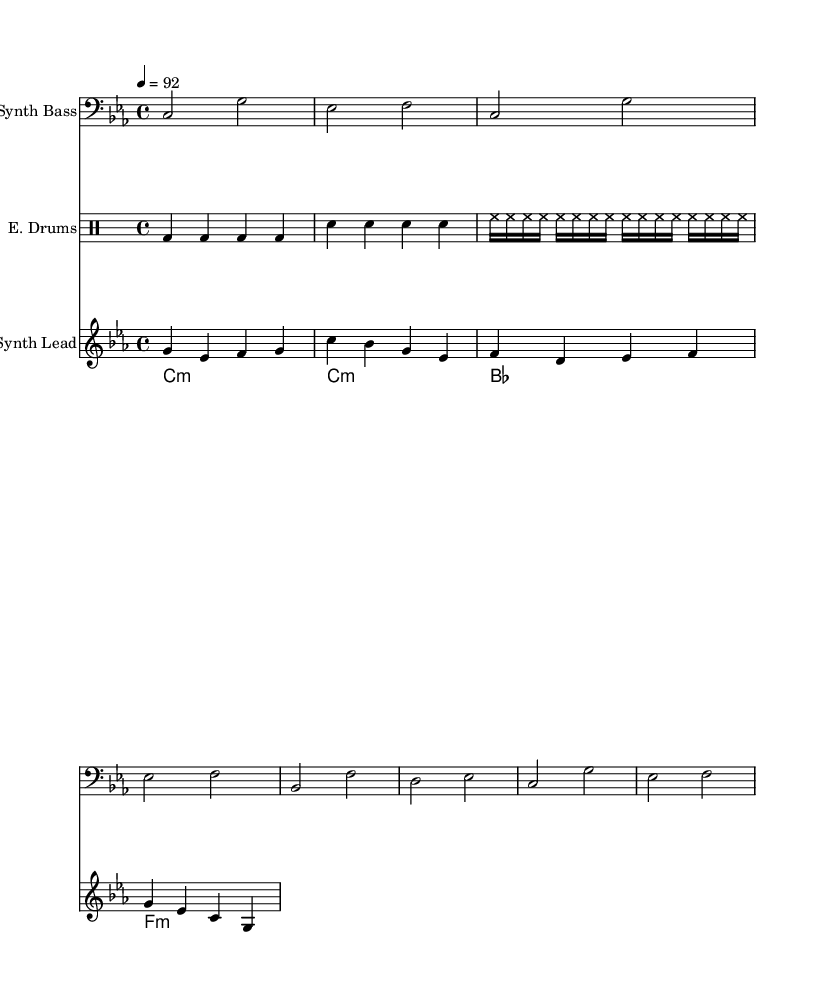What is the key signature of this music? The key signature is C minor, which is indicated by three flat notes: B flat, E flat, and A flat.
Answer: C minor What is the time signature of this music? The time signature is 4/4, which means there are four beats in each measure and the quarter note receives one beat.
Answer: 4/4 What is the tempo marking of this piece? The tempo marking is 4 equals 92, indicating that there are 92 beats per minute with the quarter note.
Answer: 92 How many different instrumental parts are in this score? There are four different instrumental parts: synth bass, electronic drums, synth lead, and pad chords. By counting the distinct sections in the score, we identify the four parts.
Answer: Four What kind of rhythmic pattern is used in the electronic drums? The electronic drums feature a consistent pattern comprising kick drums on every beat, snare drums on the second and fourth beats, and hi-hats playing sixteenth notes throughout. This syncopated feel is typical in Rap music.
Answer: Syncopated Does the synth bass play a melody or a harmonic role? The synth bass plays a melodic role, providing a distinct line that outlines the chord tones while supporting the harmonic structure of the piece. By analyzing the notes and their arrangement, it can be seen that they form a melody.
Answer: Melodic 